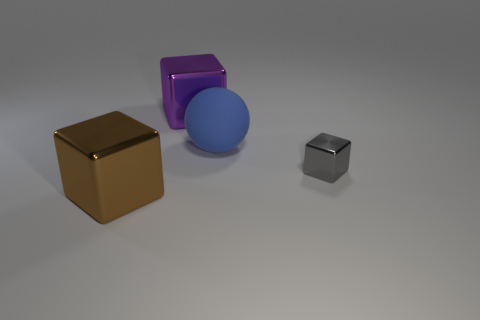The metallic thing in front of the tiny gray block is what color?
Offer a terse response. Brown. The metal thing that is behind the large blue object has what shape?
Make the answer very short. Cube. How many green objects are tiny metal things or balls?
Provide a succinct answer. 0. Do the gray cube and the blue thing have the same material?
Provide a succinct answer. No. There is a large brown shiny cube; what number of big shiny cubes are on the right side of it?
Offer a very short reply. 1. What is the thing that is both left of the gray metallic block and on the right side of the purple shiny object made of?
Offer a very short reply. Rubber. How many cylinders are shiny objects or cyan shiny things?
Provide a succinct answer. 0. The gray block that is made of the same material as the big purple block is what size?
Your response must be concise. Small. There is a large thing that is in front of the tiny gray thing; is it the same shape as the big metal thing that is behind the gray metal thing?
Make the answer very short. Yes. There is a large thing that is made of the same material as the big brown cube; what is its color?
Make the answer very short. Purple. 